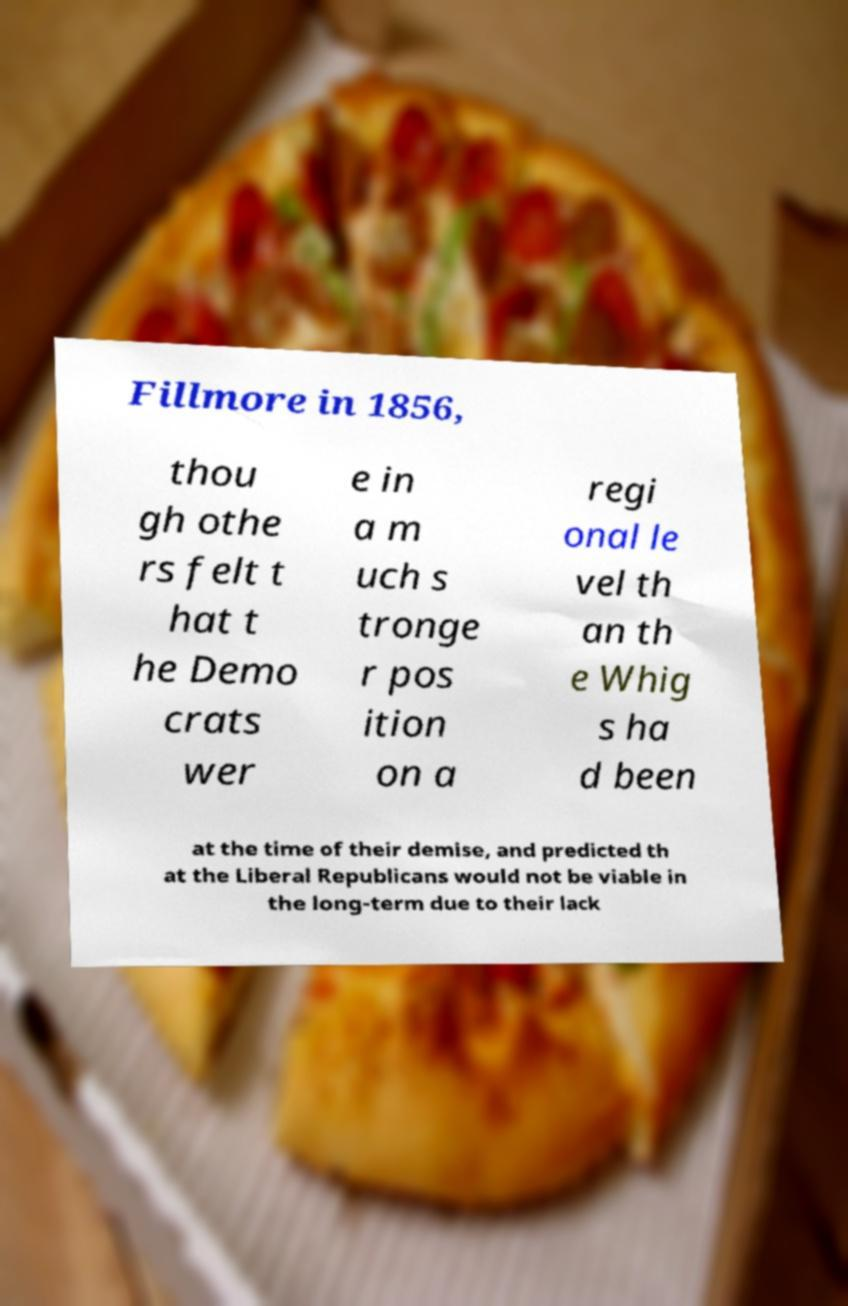Can you read and provide the text displayed in the image?This photo seems to have some interesting text. Can you extract and type it out for me? Fillmore in 1856, thou gh othe rs felt t hat t he Demo crats wer e in a m uch s tronge r pos ition on a regi onal le vel th an th e Whig s ha d been at the time of their demise, and predicted th at the Liberal Republicans would not be viable in the long-term due to their lack 